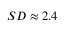Convert formula to latex. <formula><loc_0><loc_0><loc_500><loc_500>S D \approx 2 . 4</formula> 